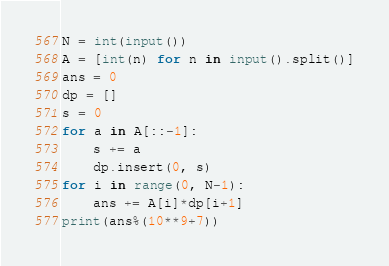Convert code to text. <code><loc_0><loc_0><loc_500><loc_500><_Python_>N = int(input())
A = [int(n) for n in input().split()]
ans = 0
dp = []
s = 0
for a in A[::-1]:
    s += a
    dp.insert(0, s)
for i in range(0, N-1):
    ans += A[i]*dp[i+1]
print(ans%(10**9+7))
</code> 